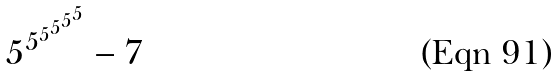Convert formula to latex. <formula><loc_0><loc_0><loc_500><loc_500>5 ^ { 5 ^ { 5 ^ { 5 ^ { 5 ^ { 5 } } } } } - 7</formula> 